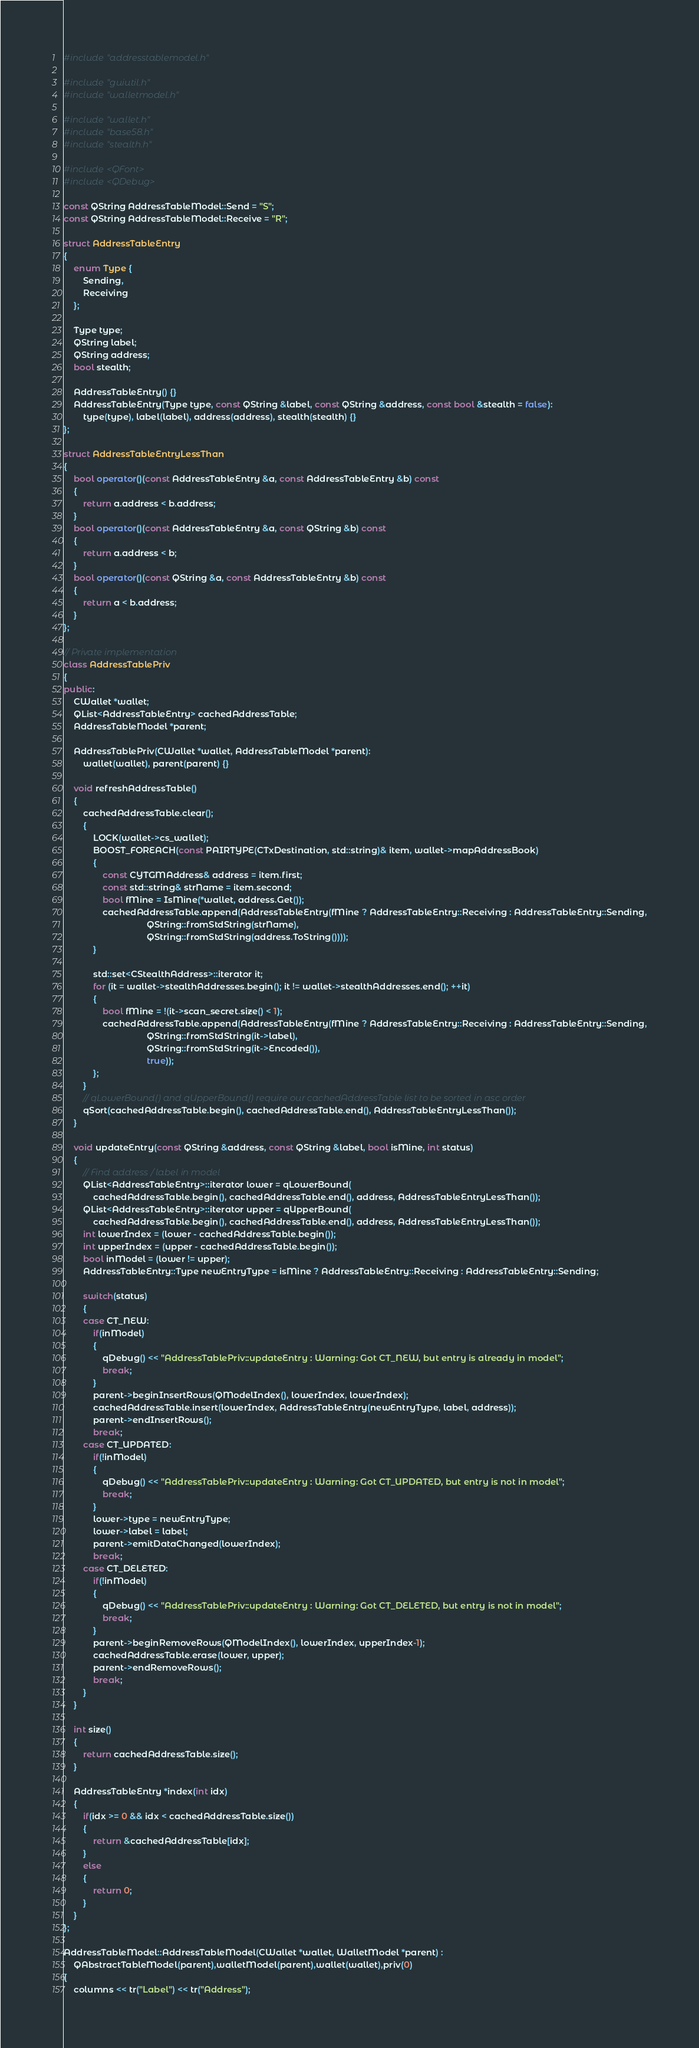Convert code to text. <code><loc_0><loc_0><loc_500><loc_500><_C++_>#include "addresstablemodel.h"

#include "guiutil.h"
#include "walletmodel.h"

#include "wallet.h"
#include "base58.h"
#include "stealth.h"

#include <QFont>
#include <QDebug>

const QString AddressTableModel::Send = "S";
const QString AddressTableModel::Receive = "R";

struct AddressTableEntry
{
    enum Type {
        Sending,
        Receiving
    };

    Type type;
    QString label;
    QString address;
    bool stealth;

    AddressTableEntry() {}
    AddressTableEntry(Type type, const QString &label, const QString &address, const bool &stealth = false):
        type(type), label(label), address(address), stealth(stealth) {}
};

struct AddressTableEntryLessThan
{
    bool operator()(const AddressTableEntry &a, const AddressTableEntry &b) const
    {
        return a.address < b.address;
    }
    bool operator()(const AddressTableEntry &a, const QString &b) const
    {
        return a.address < b;
    }
    bool operator()(const QString &a, const AddressTableEntry &b) const
    {
        return a < b.address;
    }
};

// Private implementation
class AddressTablePriv
{
public:
    CWallet *wallet;
    QList<AddressTableEntry> cachedAddressTable;
    AddressTableModel *parent;

    AddressTablePriv(CWallet *wallet, AddressTableModel *parent):
        wallet(wallet), parent(parent) {}

    void refreshAddressTable()
    {
        cachedAddressTable.clear();
        {
            LOCK(wallet->cs_wallet);
            BOOST_FOREACH(const PAIRTYPE(CTxDestination, std::string)& item, wallet->mapAddressBook)
            {
                const CYTGMAddress& address = item.first;
                const std::string& strName = item.second;
                bool fMine = IsMine(*wallet, address.Get());
                cachedAddressTable.append(AddressTableEntry(fMine ? AddressTableEntry::Receiving : AddressTableEntry::Sending,
                                  QString::fromStdString(strName),
                                  QString::fromStdString(address.ToString())));
            }

            std::set<CStealthAddress>::iterator it;
            for (it = wallet->stealthAddresses.begin(); it != wallet->stealthAddresses.end(); ++it)
            {
                bool fMine = !(it->scan_secret.size() < 1);
                cachedAddressTable.append(AddressTableEntry(fMine ? AddressTableEntry::Receiving : AddressTableEntry::Sending,
                                  QString::fromStdString(it->label),
                                  QString::fromStdString(it->Encoded()),
                                  true));
            };
        }
        // qLowerBound() and qUpperBound() require our cachedAddressTable list to be sorted in asc order
        qSort(cachedAddressTable.begin(), cachedAddressTable.end(), AddressTableEntryLessThan());
    }

    void updateEntry(const QString &address, const QString &label, bool isMine, int status)
    {
        // Find address / label in model
        QList<AddressTableEntry>::iterator lower = qLowerBound(
            cachedAddressTable.begin(), cachedAddressTable.end(), address, AddressTableEntryLessThan());
        QList<AddressTableEntry>::iterator upper = qUpperBound(
            cachedAddressTable.begin(), cachedAddressTable.end(), address, AddressTableEntryLessThan());
        int lowerIndex = (lower - cachedAddressTable.begin());
        int upperIndex = (upper - cachedAddressTable.begin());
        bool inModel = (lower != upper);
        AddressTableEntry::Type newEntryType = isMine ? AddressTableEntry::Receiving : AddressTableEntry::Sending;

        switch(status)
        {
        case CT_NEW:
            if(inModel)
            {
                qDebug() << "AddressTablePriv::updateEntry : Warning: Got CT_NEW, but entry is already in model";
                break;
            }
            parent->beginInsertRows(QModelIndex(), lowerIndex, lowerIndex);
            cachedAddressTable.insert(lowerIndex, AddressTableEntry(newEntryType, label, address));
            parent->endInsertRows();
            break;
        case CT_UPDATED:
            if(!inModel)
            {
                qDebug() << "AddressTablePriv::updateEntry : Warning: Got CT_UPDATED, but entry is not in model";
                break;
            }
            lower->type = newEntryType;
            lower->label = label;
            parent->emitDataChanged(lowerIndex);
            break;
        case CT_DELETED:
            if(!inModel)
            {
                qDebug() << "AddressTablePriv::updateEntry : Warning: Got CT_DELETED, but entry is not in model";
                break;
            }
            parent->beginRemoveRows(QModelIndex(), lowerIndex, upperIndex-1);
            cachedAddressTable.erase(lower, upper);
            parent->endRemoveRows();
            break;
        }
    }

    int size()
    {
        return cachedAddressTable.size();
    }

    AddressTableEntry *index(int idx)
    {
        if(idx >= 0 && idx < cachedAddressTable.size())
        {
            return &cachedAddressTable[idx];
        }
        else
        {
            return 0;
        }
    }
};

AddressTableModel::AddressTableModel(CWallet *wallet, WalletModel *parent) :
    QAbstractTableModel(parent),walletModel(parent),wallet(wallet),priv(0)
{
    columns << tr("Label") << tr("Address");</code> 